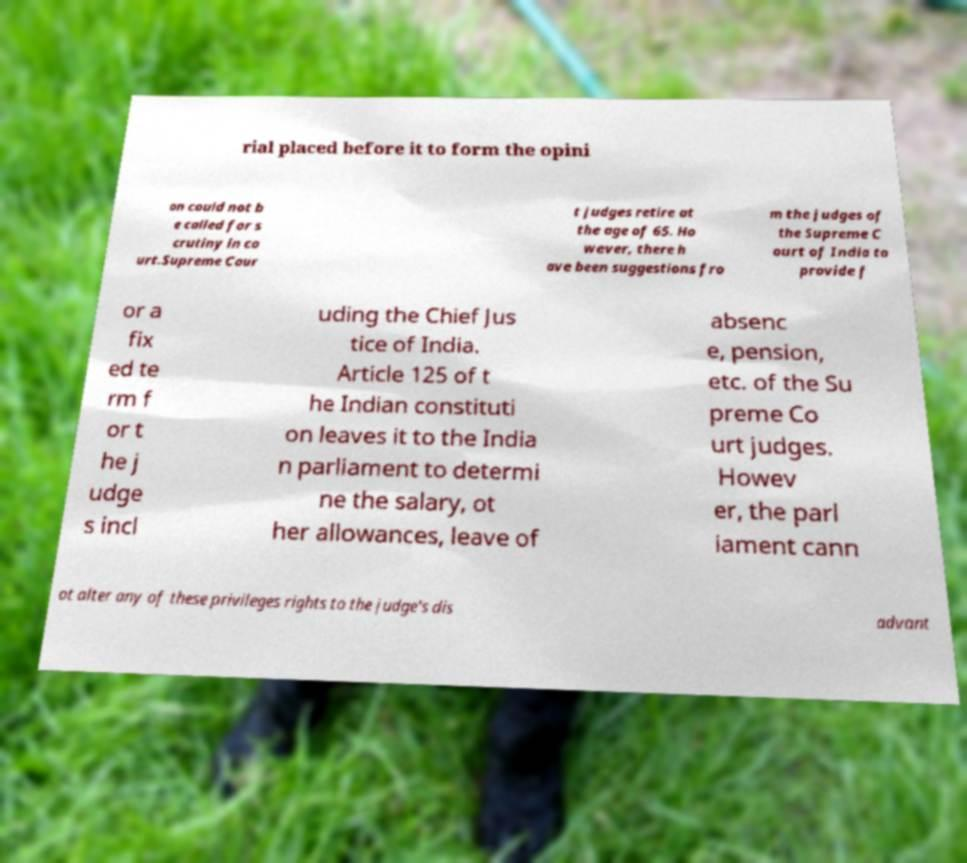For documentation purposes, I need the text within this image transcribed. Could you provide that? rial placed before it to form the opini on could not b e called for s crutiny in co urt.Supreme Cour t judges retire at the age of 65. Ho wever, there h ave been suggestions fro m the judges of the Supreme C ourt of India to provide f or a fix ed te rm f or t he j udge s incl uding the Chief Jus tice of India. Article 125 of t he Indian constituti on leaves it to the India n parliament to determi ne the salary, ot her allowances, leave of absenc e, pension, etc. of the Su preme Co urt judges. Howev er, the parl iament cann ot alter any of these privileges rights to the judge's dis advant 